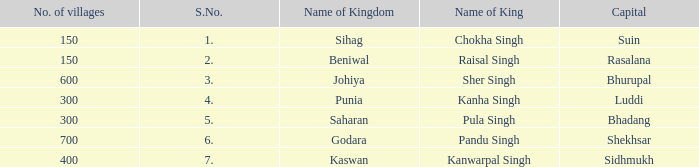Which kingdom has Suin as its capital? Sihag. Would you be able to parse every entry in this table? {'header': ['No. of villages', 'S.No.', 'Name of Kingdom', 'Name of King', 'Capital'], 'rows': [['150', '1.', 'Sihag', 'Chokha Singh', 'Suin'], ['150', '2.', 'Beniwal', 'Raisal Singh', 'Rasalana'], ['600', '3.', 'Johiya', 'Sher Singh', 'Bhurupal'], ['300', '4.', 'Punia', 'Kanha Singh', 'Luddi'], ['300', '5.', 'Saharan', 'Pula Singh', 'Bhadang'], ['700', '6.', 'Godara', 'Pandu Singh', 'Shekhsar'], ['400', '7.', 'Kaswan', 'Kanwarpal Singh', 'Sidhmukh']]} 